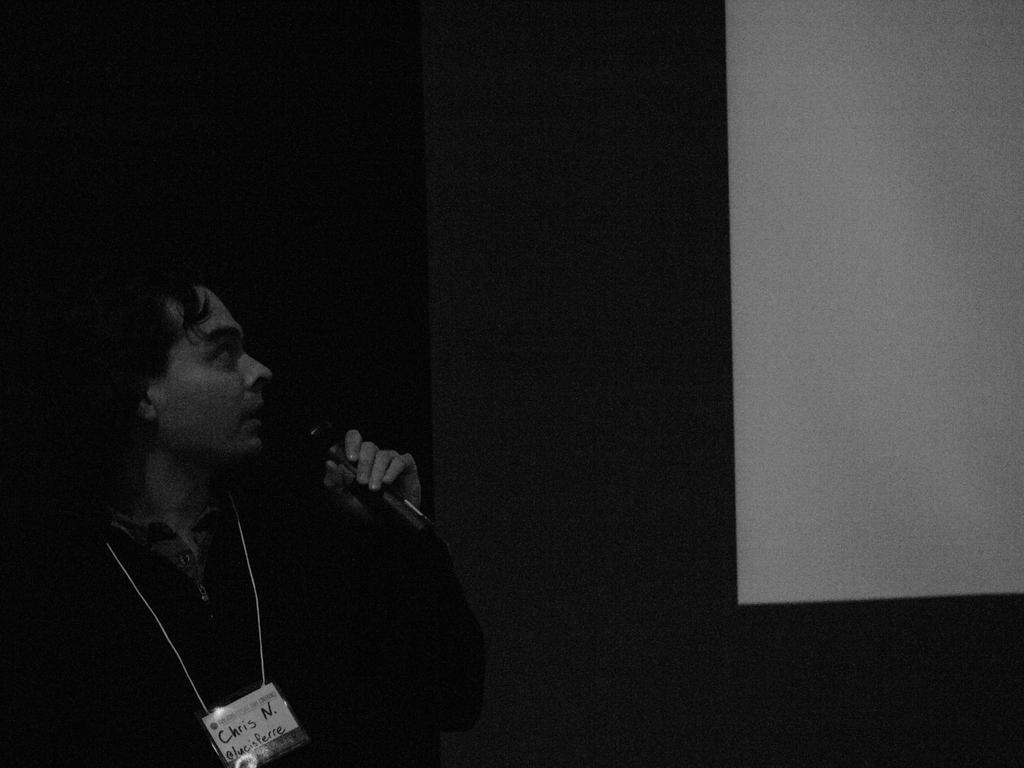What is the person in the image doing? The person is standing in the image and holding a microphone in his hand. Can you describe any accessories the person is wearing? The person has a badge around his neck. What type of deer can be seen in the background of the image? There is no deer present in the image. What reason does the person have for holding the microphone in the image? The image does not provide any information about the reason for holding the microphone. 